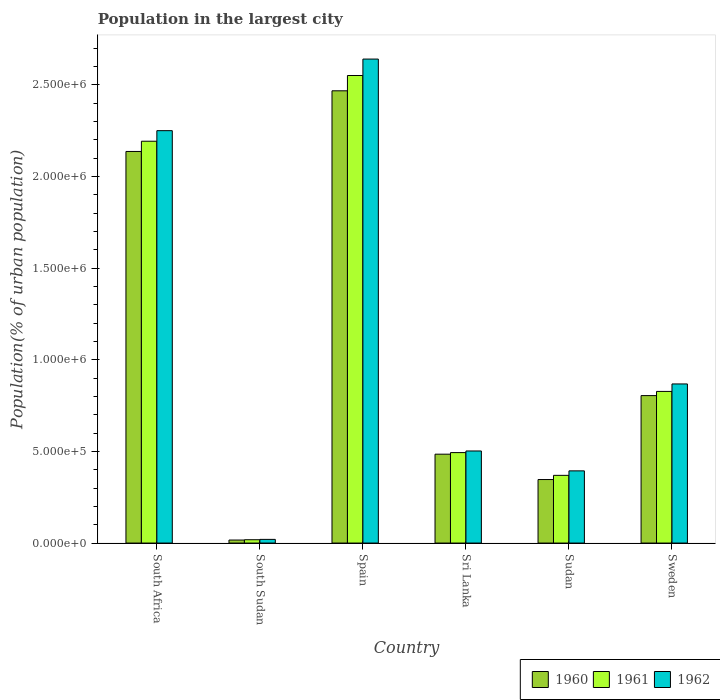How many different coloured bars are there?
Offer a terse response. 3. How many groups of bars are there?
Offer a terse response. 6. Are the number of bars per tick equal to the number of legend labels?
Offer a very short reply. Yes. What is the label of the 4th group of bars from the left?
Provide a succinct answer. Sri Lanka. What is the population in the largest city in 1962 in Sweden?
Your response must be concise. 8.68e+05. Across all countries, what is the maximum population in the largest city in 1962?
Your answer should be very brief. 2.64e+06. Across all countries, what is the minimum population in the largest city in 1961?
Offer a very short reply. 1.82e+04. In which country was the population in the largest city in 1960 minimum?
Your answer should be compact. South Sudan. What is the total population in the largest city in 1960 in the graph?
Give a very brief answer. 6.26e+06. What is the difference between the population in the largest city in 1961 in South Sudan and that in Sweden?
Provide a succinct answer. -8.09e+05. What is the difference between the population in the largest city in 1962 in Sweden and the population in the largest city in 1961 in South Africa?
Give a very brief answer. -1.32e+06. What is the average population in the largest city in 1960 per country?
Ensure brevity in your answer.  1.04e+06. What is the difference between the population in the largest city of/in 1961 and population in the largest city of/in 1962 in Sweden?
Provide a short and direct response. -4.07e+04. What is the ratio of the population in the largest city in 1960 in South Sudan to that in Sri Lanka?
Ensure brevity in your answer.  0.03. Is the difference between the population in the largest city in 1961 in South Sudan and Sudan greater than the difference between the population in the largest city in 1962 in South Sudan and Sudan?
Your answer should be compact. Yes. What is the difference between the highest and the second highest population in the largest city in 1960?
Provide a short and direct response. 1.33e+06. What is the difference between the highest and the lowest population in the largest city in 1961?
Offer a terse response. 2.53e+06. What does the 1st bar from the right in South Africa represents?
Provide a short and direct response. 1962. Is it the case that in every country, the sum of the population in the largest city in 1961 and population in the largest city in 1960 is greater than the population in the largest city in 1962?
Offer a very short reply. Yes. How many countries are there in the graph?
Offer a terse response. 6. What is the difference between two consecutive major ticks on the Y-axis?
Your response must be concise. 5.00e+05. Are the values on the major ticks of Y-axis written in scientific E-notation?
Keep it short and to the point. Yes. Does the graph contain any zero values?
Your response must be concise. No. Where does the legend appear in the graph?
Offer a terse response. Bottom right. How many legend labels are there?
Offer a very short reply. 3. What is the title of the graph?
Provide a succinct answer. Population in the largest city. Does "1999" appear as one of the legend labels in the graph?
Your answer should be compact. No. What is the label or title of the Y-axis?
Your answer should be compact. Population(% of urban population). What is the Population(% of urban population) of 1960 in South Africa?
Keep it short and to the point. 2.14e+06. What is the Population(% of urban population) of 1961 in South Africa?
Keep it short and to the point. 2.19e+06. What is the Population(% of urban population) of 1962 in South Africa?
Provide a succinct answer. 2.25e+06. What is the Population(% of urban population) of 1960 in South Sudan?
Your response must be concise. 1.65e+04. What is the Population(% of urban population) of 1961 in South Sudan?
Ensure brevity in your answer.  1.82e+04. What is the Population(% of urban population) of 1962 in South Sudan?
Offer a terse response. 2.00e+04. What is the Population(% of urban population) of 1960 in Spain?
Offer a very short reply. 2.47e+06. What is the Population(% of urban population) in 1961 in Spain?
Give a very brief answer. 2.55e+06. What is the Population(% of urban population) in 1962 in Spain?
Your response must be concise. 2.64e+06. What is the Population(% of urban population) in 1960 in Sri Lanka?
Give a very brief answer. 4.85e+05. What is the Population(% of urban population) in 1961 in Sri Lanka?
Make the answer very short. 4.94e+05. What is the Population(% of urban population) in 1962 in Sri Lanka?
Provide a succinct answer. 5.02e+05. What is the Population(% of urban population) in 1960 in Sudan?
Your response must be concise. 3.47e+05. What is the Population(% of urban population) of 1961 in Sudan?
Your answer should be compact. 3.69e+05. What is the Population(% of urban population) of 1962 in Sudan?
Your answer should be very brief. 3.94e+05. What is the Population(% of urban population) in 1960 in Sweden?
Offer a very short reply. 8.05e+05. What is the Population(% of urban population) in 1961 in Sweden?
Provide a succinct answer. 8.27e+05. What is the Population(% of urban population) of 1962 in Sweden?
Give a very brief answer. 8.68e+05. Across all countries, what is the maximum Population(% of urban population) of 1960?
Ensure brevity in your answer.  2.47e+06. Across all countries, what is the maximum Population(% of urban population) in 1961?
Ensure brevity in your answer.  2.55e+06. Across all countries, what is the maximum Population(% of urban population) of 1962?
Provide a succinct answer. 2.64e+06. Across all countries, what is the minimum Population(% of urban population) in 1960?
Give a very brief answer. 1.65e+04. Across all countries, what is the minimum Population(% of urban population) in 1961?
Ensure brevity in your answer.  1.82e+04. What is the total Population(% of urban population) of 1960 in the graph?
Your answer should be compact. 6.26e+06. What is the total Population(% of urban population) in 1961 in the graph?
Make the answer very short. 6.45e+06. What is the total Population(% of urban population) in 1962 in the graph?
Your response must be concise. 6.68e+06. What is the difference between the Population(% of urban population) in 1960 in South Africa and that in South Sudan?
Your response must be concise. 2.12e+06. What is the difference between the Population(% of urban population) in 1961 in South Africa and that in South Sudan?
Make the answer very short. 2.17e+06. What is the difference between the Population(% of urban population) of 1962 in South Africa and that in South Sudan?
Ensure brevity in your answer.  2.23e+06. What is the difference between the Population(% of urban population) in 1960 in South Africa and that in Spain?
Ensure brevity in your answer.  -3.31e+05. What is the difference between the Population(% of urban population) in 1961 in South Africa and that in Spain?
Give a very brief answer. -3.59e+05. What is the difference between the Population(% of urban population) in 1962 in South Africa and that in Spain?
Your answer should be very brief. -3.91e+05. What is the difference between the Population(% of urban population) of 1960 in South Africa and that in Sri Lanka?
Provide a succinct answer. 1.65e+06. What is the difference between the Population(% of urban population) in 1961 in South Africa and that in Sri Lanka?
Provide a succinct answer. 1.70e+06. What is the difference between the Population(% of urban population) of 1962 in South Africa and that in Sri Lanka?
Your answer should be compact. 1.75e+06. What is the difference between the Population(% of urban population) of 1960 in South Africa and that in Sudan?
Your answer should be very brief. 1.79e+06. What is the difference between the Population(% of urban population) in 1961 in South Africa and that in Sudan?
Your answer should be very brief. 1.82e+06. What is the difference between the Population(% of urban population) in 1962 in South Africa and that in Sudan?
Offer a very short reply. 1.86e+06. What is the difference between the Population(% of urban population) in 1960 in South Africa and that in Sweden?
Provide a succinct answer. 1.33e+06. What is the difference between the Population(% of urban population) of 1961 in South Africa and that in Sweden?
Your answer should be very brief. 1.37e+06. What is the difference between the Population(% of urban population) in 1962 in South Africa and that in Sweden?
Your response must be concise. 1.38e+06. What is the difference between the Population(% of urban population) in 1960 in South Sudan and that in Spain?
Offer a very short reply. -2.45e+06. What is the difference between the Population(% of urban population) of 1961 in South Sudan and that in Spain?
Offer a very short reply. -2.53e+06. What is the difference between the Population(% of urban population) of 1962 in South Sudan and that in Spain?
Your answer should be compact. -2.62e+06. What is the difference between the Population(% of urban population) in 1960 in South Sudan and that in Sri Lanka?
Give a very brief answer. -4.68e+05. What is the difference between the Population(% of urban population) of 1961 in South Sudan and that in Sri Lanka?
Give a very brief answer. -4.75e+05. What is the difference between the Population(% of urban population) in 1962 in South Sudan and that in Sri Lanka?
Keep it short and to the point. -4.82e+05. What is the difference between the Population(% of urban population) of 1960 in South Sudan and that in Sudan?
Ensure brevity in your answer.  -3.30e+05. What is the difference between the Population(% of urban population) in 1961 in South Sudan and that in Sudan?
Give a very brief answer. -3.51e+05. What is the difference between the Population(% of urban population) of 1962 in South Sudan and that in Sudan?
Your response must be concise. -3.74e+05. What is the difference between the Population(% of urban population) in 1960 in South Sudan and that in Sweden?
Your answer should be very brief. -7.88e+05. What is the difference between the Population(% of urban population) in 1961 in South Sudan and that in Sweden?
Provide a short and direct response. -8.09e+05. What is the difference between the Population(% of urban population) in 1962 in South Sudan and that in Sweden?
Offer a very short reply. -8.48e+05. What is the difference between the Population(% of urban population) of 1960 in Spain and that in Sri Lanka?
Ensure brevity in your answer.  1.98e+06. What is the difference between the Population(% of urban population) of 1961 in Spain and that in Sri Lanka?
Provide a short and direct response. 2.06e+06. What is the difference between the Population(% of urban population) in 1962 in Spain and that in Sri Lanka?
Give a very brief answer. 2.14e+06. What is the difference between the Population(% of urban population) in 1960 in Spain and that in Sudan?
Ensure brevity in your answer.  2.12e+06. What is the difference between the Population(% of urban population) of 1961 in Spain and that in Sudan?
Offer a terse response. 2.18e+06. What is the difference between the Population(% of urban population) of 1962 in Spain and that in Sudan?
Provide a short and direct response. 2.25e+06. What is the difference between the Population(% of urban population) in 1960 in Spain and that in Sweden?
Offer a very short reply. 1.66e+06. What is the difference between the Population(% of urban population) in 1961 in Spain and that in Sweden?
Keep it short and to the point. 1.72e+06. What is the difference between the Population(% of urban population) of 1962 in Spain and that in Sweden?
Provide a succinct answer. 1.77e+06. What is the difference between the Population(% of urban population) in 1960 in Sri Lanka and that in Sudan?
Give a very brief answer. 1.38e+05. What is the difference between the Population(% of urban population) of 1961 in Sri Lanka and that in Sudan?
Keep it short and to the point. 1.24e+05. What is the difference between the Population(% of urban population) of 1962 in Sri Lanka and that in Sudan?
Your response must be concise. 1.09e+05. What is the difference between the Population(% of urban population) of 1960 in Sri Lanka and that in Sweden?
Offer a terse response. -3.20e+05. What is the difference between the Population(% of urban population) of 1961 in Sri Lanka and that in Sweden?
Your answer should be very brief. -3.34e+05. What is the difference between the Population(% of urban population) in 1962 in Sri Lanka and that in Sweden?
Keep it short and to the point. -3.66e+05. What is the difference between the Population(% of urban population) in 1960 in Sudan and that in Sweden?
Offer a very short reply. -4.58e+05. What is the difference between the Population(% of urban population) in 1961 in Sudan and that in Sweden?
Offer a very short reply. -4.58e+05. What is the difference between the Population(% of urban population) in 1962 in Sudan and that in Sweden?
Offer a terse response. -4.74e+05. What is the difference between the Population(% of urban population) of 1960 in South Africa and the Population(% of urban population) of 1961 in South Sudan?
Give a very brief answer. 2.12e+06. What is the difference between the Population(% of urban population) in 1960 in South Africa and the Population(% of urban population) in 1962 in South Sudan?
Your answer should be very brief. 2.12e+06. What is the difference between the Population(% of urban population) in 1961 in South Africa and the Population(% of urban population) in 1962 in South Sudan?
Offer a terse response. 2.17e+06. What is the difference between the Population(% of urban population) of 1960 in South Africa and the Population(% of urban population) of 1961 in Spain?
Offer a very short reply. -4.14e+05. What is the difference between the Population(% of urban population) of 1960 in South Africa and the Population(% of urban population) of 1962 in Spain?
Your response must be concise. -5.04e+05. What is the difference between the Population(% of urban population) in 1961 in South Africa and the Population(% of urban population) in 1962 in Spain?
Make the answer very short. -4.48e+05. What is the difference between the Population(% of urban population) in 1960 in South Africa and the Population(% of urban population) in 1961 in Sri Lanka?
Your answer should be very brief. 1.64e+06. What is the difference between the Population(% of urban population) in 1960 in South Africa and the Population(% of urban population) in 1962 in Sri Lanka?
Ensure brevity in your answer.  1.63e+06. What is the difference between the Population(% of urban population) in 1961 in South Africa and the Population(% of urban population) in 1962 in Sri Lanka?
Provide a short and direct response. 1.69e+06. What is the difference between the Population(% of urban population) in 1960 in South Africa and the Population(% of urban population) in 1961 in Sudan?
Ensure brevity in your answer.  1.77e+06. What is the difference between the Population(% of urban population) in 1960 in South Africa and the Population(% of urban population) in 1962 in Sudan?
Provide a succinct answer. 1.74e+06. What is the difference between the Population(% of urban population) in 1961 in South Africa and the Population(% of urban population) in 1962 in Sudan?
Give a very brief answer. 1.80e+06. What is the difference between the Population(% of urban population) in 1960 in South Africa and the Population(% of urban population) in 1961 in Sweden?
Offer a terse response. 1.31e+06. What is the difference between the Population(% of urban population) in 1960 in South Africa and the Population(% of urban population) in 1962 in Sweden?
Make the answer very short. 1.27e+06. What is the difference between the Population(% of urban population) in 1961 in South Africa and the Population(% of urban population) in 1962 in Sweden?
Provide a succinct answer. 1.32e+06. What is the difference between the Population(% of urban population) in 1960 in South Sudan and the Population(% of urban population) in 1961 in Spain?
Offer a terse response. -2.53e+06. What is the difference between the Population(% of urban population) of 1960 in South Sudan and the Population(% of urban population) of 1962 in Spain?
Your answer should be very brief. -2.62e+06. What is the difference between the Population(% of urban population) in 1961 in South Sudan and the Population(% of urban population) in 1962 in Spain?
Offer a terse response. -2.62e+06. What is the difference between the Population(% of urban population) of 1960 in South Sudan and the Population(% of urban population) of 1961 in Sri Lanka?
Offer a terse response. -4.77e+05. What is the difference between the Population(% of urban population) in 1960 in South Sudan and the Population(% of urban population) in 1962 in Sri Lanka?
Offer a terse response. -4.86e+05. What is the difference between the Population(% of urban population) of 1961 in South Sudan and the Population(% of urban population) of 1962 in Sri Lanka?
Your response must be concise. -4.84e+05. What is the difference between the Population(% of urban population) in 1960 in South Sudan and the Population(% of urban population) in 1961 in Sudan?
Keep it short and to the point. -3.53e+05. What is the difference between the Population(% of urban population) in 1960 in South Sudan and the Population(% of urban population) in 1962 in Sudan?
Keep it short and to the point. -3.77e+05. What is the difference between the Population(% of urban population) in 1961 in South Sudan and the Population(% of urban population) in 1962 in Sudan?
Your answer should be compact. -3.76e+05. What is the difference between the Population(% of urban population) in 1960 in South Sudan and the Population(% of urban population) in 1961 in Sweden?
Your answer should be very brief. -8.11e+05. What is the difference between the Population(% of urban population) in 1960 in South Sudan and the Population(% of urban population) in 1962 in Sweden?
Offer a terse response. -8.52e+05. What is the difference between the Population(% of urban population) of 1961 in South Sudan and the Population(% of urban population) of 1962 in Sweden?
Keep it short and to the point. -8.50e+05. What is the difference between the Population(% of urban population) of 1960 in Spain and the Population(% of urban population) of 1961 in Sri Lanka?
Offer a terse response. 1.97e+06. What is the difference between the Population(% of urban population) in 1960 in Spain and the Population(% of urban population) in 1962 in Sri Lanka?
Offer a terse response. 1.97e+06. What is the difference between the Population(% of urban population) of 1961 in Spain and the Population(% of urban population) of 1962 in Sri Lanka?
Keep it short and to the point. 2.05e+06. What is the difference between the Population(% of urban population) of 1960 in Spain and the Population(% of urban population) of 1961 in Sudan?
Your answer should be compact. 2.10e+06. What is the difference between the Population(% of urban population) in 1960 in Spain and the Population(% of urban population) in 1962 in Sudan?
Your answer should be very brief. 2.07e+06. What is the difference between the Population(% of urban population) in 1961 in Spain and the Population(% of urban population) in 1962 in Sudan?
Your response must be concise. 2.16e+06. What is the difference between the Population(% of urban population) in 1960 in Spain and the Population(% of urban population) in 1961 in Sweden?
Offer a terse response. 1.64e+06. What is the difference between the Population(% of urban population) in 1960 in Spain and the Population(% of urban population) in 1962 in Sweden?
Your response must be concise. 1.60e+06. What is the difference between the Population(% of urban population) in 1961 in Spain and the Population(% of urban population) in 1962 in Sweden?
Offer a very short reply. 1.68e+06. What is the difference between the Population(% of urban population) in 1960 in Sri Lanka and the Population(% of urban population) in 1961 in Sudan?
Keep it short and to the point. 1.15e+05. What is the difference between the Population(% of urban population) of 1960 in Sri Lanka and the Population(% of urban population) of 1962 in Sudan?
Provide a short and direct response. 9.11e+04. What is the difference between the Population(% of urban population) in 1961 in Sri Lanka and the Population(% of urban population) in 1962 in Sudan?
Your response must be concise. 9.97e+04. What is the difference between the Population(% of urban population) of 1960 in Sri Lanka and the Population(% of urban population) of 1961 in Sweden?
Offer a very short reply. -3.43e+05. What is the difference between the Population(% of urban population) of 1960 in Sri Lanka and the Population(% of urban population) of 1962 in Sweden?
Your answer should be compact. -3.83e+05. What is the difference between the Population(% of urban population) in 1961 in Sri Lanka and the Population(% of urban population) in 1962 in Sweden?
Offer a very short reply. -3.75e+05. What is the difference between the Population(% of urban population) of 1960 in Sudan and the Population(% of urban population) of 1961 in Sweden?
Keep it short and to the point. -4.81e+05. What is the difference between the Population(% of urban population) of 1960 in Sudan and the Population(% of urban population) of 1962 in Sweden?
Your answer should be compact. -5.22e+05. What is the difference between the Population(% of urban population) of 1961 in Sudan and the Population(% of urban population) of 1962 in Sweden?
Keep it short and to the point. -4.99e+05. What is the average Population(% of urban population) in 1960 per country?
Ensure brevity in your answer.  1.04e+06. What is the average Population(% of urban population) of 1961 per country?
Ensure brevity in your answer.  1.08e+06. What is the average Population(% of urban population) of 1962 per country?
Provide a succinct answer. 1.11e+06. What is the difference between the Population(% of urban population) of 1960 and Population(% of urban population) of 1961 in South Africa?
Ensure brevity in your answer.  -5.59e+04. What is the difference between the Population(% of urban population) of 1960 and Population(% of urban population) of 1962 in South Africa?
Your answer should be compact. -1.14e+05. What is the difference between the Population(% of urban population) in 1961 and Population(% of urban population) in 1962 in South Africa?
Your answer should be very brief. -5.76e+04. What is the difference between the Population(% of urban population) of 1960 and Population(% of urban population) of 1961 in South Sudan?
Keep it short and to the point. -1675. What is the difference between the Population(% of urban population) of 1960 and Population(% of urban population) of 1962 in South Sudan?
Offer a very short reply. -3523. What is the difference between the Population(% of urban population) of 1961 and Population(% of urban population) of 1962 in South Sudan?
Provide a short and direct response. -1848. What is the difference between the Population(% of urban population) in 1960 and Population(% of urban population) in 1961 in Spain?
Offer a very short reply. -8.34e+04. What is the difference between the Population(% of urban population) of 1960 and Population(% of urban population) of 1962 in Spain?
Offer a very short reply. -1.73e+05. What is the difference between the Population(% of urban population) of 1961 and Population(% of urban population) of 1962 in Spain?
Offer a very short reply. -8.97e+04. What is the difference between the Population(% of urban population) in 1960 and Population(% of urban population) in 1961 in Sri Lanka?
Keep it short and to the point. -8675. What is the difference between the Population(% of urban population) in 1960 and Population(% of urban population) in 1962 in Sri Lanka?
Offer a terse response. -1.75e+04. What is the difference between the Population(% of urban population) in 1961 and Population(% of urban population) in 1962 in Sri Lanka?
Your response must be concise. -8842. What is the difference between the Population(% of urban population) of 1960 and Population(% of urban population) of 1961 in Sudan?
Make the answer very short. -2.29e+04. What is the difference between the Population(% of urban population) in 1960 and Population(% of urban population) in 1962 in Sudan?
Your answer should be compact. -4.73e+04. What is the difference between the Population(% of urban population) of 1961 and Population(% of urban population) of 1962 in Sudan?
Ensure brevity in your answer.  -2.44e+04. What is the difference between the Population(% of urban population) of 1960 and Population(% of urban population) of 1961 in Sweden?
Make the answer very short. -2.29e+04. What is the difference between the Population(% of urban population) of 1960 and Population(% of urban population) of 1962 in Sweden?
Ensure brevity in your answer.  -6.36e+04. What is the difference between the Population(% of urban population) in 1961 and Population(% of urban population) in 1962 in Sweden?
Provide a succinct answer. -4.07e+04. What is the ratio of the Population(% of urban population) in 1960 in South Africa to that in South Sudan?
Your response must be concise. 129.69. What is the ratio of the Population(% of urban population) of 1961 in South Africa to that in South Sudan?
Offer a very short reply. 120.8. What is the ratio of the Population(% of urban population) in 1962 in South Africa to that in South Sudan?
Your response must be concise. 112.52. What is the ratio of the Population(% of urban population) in 1960 in South Africa to that in Spain?
Offer a terse response. 0.87. What is the ratio of the Population(% of urban population) of 1961 in South Africa to that in Spain?
Your answer should be compact. 0.86. What is the ratio of the Population(% of urban population) in 1962 in South Africa to that in Spain?
Provide a short and direct response. 0.85. What is the ratio of the Population(% of urban population) in 1960 in South Africa to that in Sri Lanka?
Your answer should be compact. 4.41. What is the ratio of the Population(% of urban population) of 1961 in South Africa to that in Sri Lanka?
Your answer should be very brief. 4.44. What is the ratio of the Population(% of urban population) of 1962 in South Africa to that in Sri Lanka?
Provide a succinct answer. 4.48. What is the ratio of the Population(% of urban population) of 1960 in South Africa to that in Sudan?
Provide a succinct answer. 6.17. What is the ratio of the Population(% of urban population) in 1961 in South Africa to that in Sudan?
Make the answer very short. 5.93. What is the ratio of the Population(% of urban population) of 1962 in South Africa to that in Sudan?
Make the answer very short. 5.71. What is the ratio of the Population(% of urban population) of 1960 in South Africa to that in Sweden?
Ensure brevity in your answer.  2.66. What is the ratio of the Population(% of urban population) of 1961 in South Africa to that in Sweden?
Offer a very short reply. 2.65. What is the ratio of the Population(% of urban population) of 1962 in South Africa to that in Sweden?
Your answer should be very brief. 2.59. What is the ratio of the Population(% of urban population) in 1960 in South Sudan to that in Spain?
Keep it short and to the point. 0.01. What is the ratio of the Population(% of urban population) in 1961 in South Sudan to that in Spain?
Your response must be concise. 0.01. What is the ratio of the Population(% of urban population) of 1962 in South Sudan to that in Spain?
Give a very brief answer. 0.01. What is the ratio of the Population(% of urban population) of 1960 in South Sudan to that in Sri Lanka?
Your answer should be very brief. 0.03. What is the ratio of the Population(% of urban population) of 1961 in South Sudan to that in Sri Lanka?
Offer a very short reply. 0.04. What is the ratio of the Population(% of urban population) in 1962 in South Sudan to that in Sri Lanka?
Give a very brief answer. 0.04. What is the ratio of the Population(% of urban population) of 1960 in South Sudan to that in Sudan?
Make the answer very short. 0.05. What is the ratio of the Population(% of urban population) in 1961 in South Sudan to that in Sudan?
Offer a terse response. 0.05. What is the ratio of the Population(% of urban population) in 1962 in South Sudan to that in Sudan?
Your response must be concise. 0.05. What is the ratio of the Population(% of urban population) in 1960 in South Sudan to that in Sweden?
Provide a succinct answer. 0.02. What is the ratio of the Population(% of urban population) in 1961 in South Sudan to that in Sweden?
Your answer should be very brief. 0.02. What is the ratio of the Population(% of urban population) in 1962 in South Sudan to that in Sweden?
Give a very brief answer. 0.02. What is the ratio of the Population(% of urban population) in 1960 in Spain to that in Sri Lanka?
Your answer should be compact. 5.09. What is the ratio of the Population(% of urban population) of 1961 in Spain to that in Sri Lanka?
Your answer should be compact. 5.17. What is the ratio of the Population(% of urban population) of 1962 in Spain to that in Sri Lanka?
Make the answer very short. 5.26. What is the ratio of the Population(% of urban population) of 1960 in Spain to that in Sudan?
Offer a very short reply. 7.12. What is the ratio of the Population(% of urban population) of 1961 in Spain to that in Sudan?
Ensure brevity in your answer.  6.91. What is the ratio of the Population(% of urban population) of 1962 in Spain to that in Sudan?
Your response must be concise. 6.7. What is the ratio of the Population(% of urban population) of 1960 in Spain to that in Sweden?
Offer a very short reply. 3.07. What is the ratio of the Population(% of urban population) in 1961 in Spain to that in Sweden?
Provide a succinct answer. 3.08. What is the ratio of the Population(% of urban population) in 1962 in Spain to that in Sweden?
Make the answer very short. 3.04. What is the ratio of the Population(% of urban population) of 1960 in Sri Lanka to that in Sudan?
Offer a very short reply. 1.4. What is the ratio of the Population(% of urban population) in 1961 in Sri Lanka to that in Sudan?
Offer a terse response. 1.34. What is the ratio of the Population(% of urban population) of 1962 in Sri Lanka to that in Sudan?
Your answer should be compact. 1.28. What is the ratio of the Population(% of urban population) of 1960 in Sri Lanka to that in Sweden?
Give a very brief answer. 0.6. What is the ratio of the Population(% of urban population) in 1961 in Sri Lanka to that in Sweden?
Your answer should be compact. 0.6. What is the ratio of the Population(% of urban population) in 1962 in Sri Lanka to that in Sweden?
Make the answer very short. 0.58. What is the ratio of the Population(% of urban population) of 1960 in Sudan to that in Sweden?
Give a very brief answer. 0.43. What is the ratio of the Population(% of urban population) in 1961 in Sudan to that in Sweden?
Make the answer very short. 0.45. What is the ratio of the Population(% of urban population) in 1962 in Sudan to that in Sweden?
Provide a succinct answer. 0.45. What is the difference between the highest and the second highest Population(% of urban population) of 1960?
Make the answer very short. 3.31e+05. What is the difference between the highest and the second highest Population(% of urban population) of 1961?
Provide a short and direct response. 3.59e+05. What is the difference between the highest and the second highest Population(% of urban population) of 1962?
Your answer should be very brief. 3.91e+05. What is the difference between the highest and the lowest Population(% of urban population) in 1960?
Your answer should be compact. 2.45e+06. What is the difference between the highest and the lowest Population(% of urban population) of 1961?
Give a very brief answer. 2.53e+06. What is the difference between the highest and the lowest Population(% of urban population) of 1962?
Make the answer very short. 2.62e+06. 